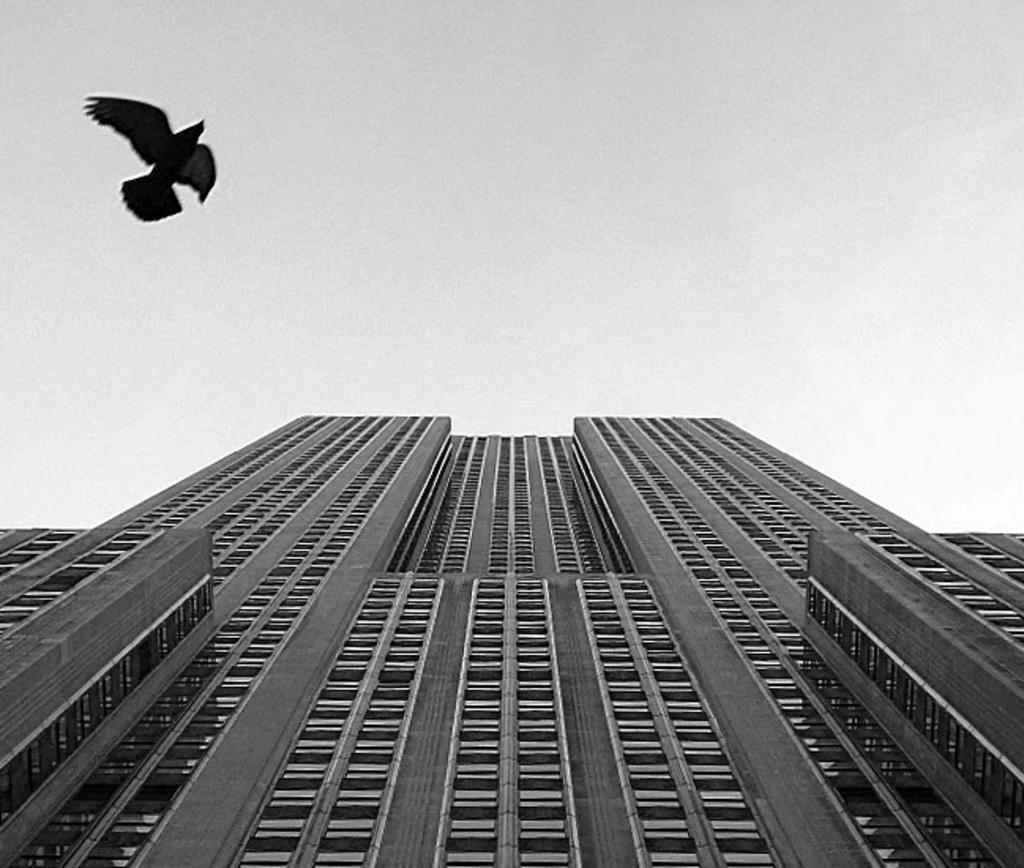In one or two sentences, can you explain what this image depicts? This is a black and white image. In this image we can see a building and a bird. In the background we can see the sky.   